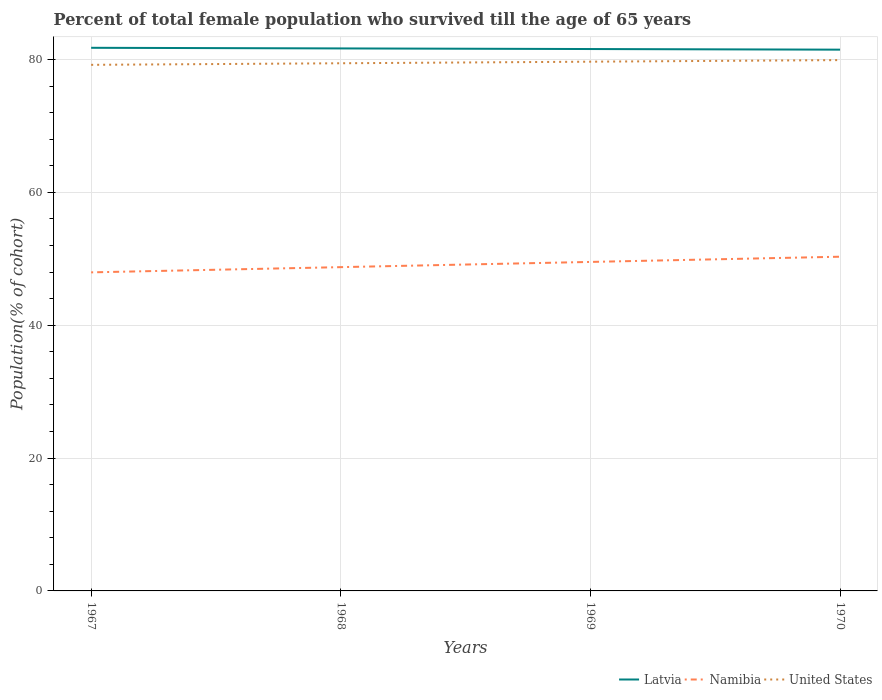Is the number of lines equal to the number of legend labels?
Provide a short and direct response. Yes. Across all years, what is the maximum percentage of total female population who survived till the age of 65 years in United States?
Offer a very short reply. 79.19. In which year was the percentage of total female population who survived till the age of 65 years in Namibia maximum?
Your response must be concise. 1967. What is the total percentage of total female population who survived till the age of 65 years in Namibia in the graph?
Offer a very short reply. -0.78. What is the difference between the highest and the second highest percentage of total female population who survived till the age of 65 years in Namibia?
Give a very brief answer. 2.35. What is the difference between the highest and the lowest percentage of total female population who survived till the age of 65 years in Namibia?
Provide a short and direct response. 2. How many lines are there?
Your response must be concise. 3. What is the difference between two consecutive major ticks on the Y-axis?
Provide a succinct answer. 20. Are the values on the major ticks of Y-axis written in scientific E-notation?
Make the answer very short. No. Does the graph contain any zero values?
Provide a succinct answer. No. Where does the legend appear in the graph?
Provide a succinct answer. Bottom right. How many legend labels are there?
Ensure brevity in your answer.  3. How are the legend labels stacked?
Offer a very short reply. Horizontal. What is the title of the graph?
Your response must be concise. Percent of total female population who survived till the age of 65 years. What is the label or title of the Y-axis?
Your response must be concise. Population(% of cohort). What is the Population(% of cohort) of Latvia in 1967?
Your answer should be compact. 81.76. What is the Population(% of cohort) in Namibia in 1967?
Your response must be concise. 47.95. What is the Population(% of cohort) in United States in 1967?
Your response must be concise. 79.19. What is the Population(% of cohort) of Latvia in 1968?
Your response must be concise. 81.66. What is the Population(% of cohort) in Namibia in 1968?
Your answer should be very brief. 48.74. What is the Population(% of cohort) in United States in 1968?
Offer a terse response. 79.43. What is the Population(% of cohort) in Latvia in 1969?
Your answer should be very brief. 81.57. What is the Population(% of cohort) in Namibia in 1969?
Make the answer very short. 49.52. What is the Population(% of cohort) in United States in 1969?
Ensure brevity in your answer.  79.67. What is the Population(% of cohort) of Latvia in 1970?
Keep it short and to the point. 81.48. What is the Population(% of cohort) in Namibia in 1970?
Ensure brevity in your answer.  50.31. What is the Population(% of cohort) of United States in 1970?
Keep it short and to the point. 79.9. Across all years, what is the maximum Population(% of cohort) of Latvia?
Keep it short and to the point. 81.76. Across all years, what is the maximum Population(% of cohort) in Namibia?
Offer a terse response. 50.31. Across all years, what is the maximum Population(% of cohort) in United States?
Your answer should be compact. 79.9. Across all years, what is the minimum Population(% of cohort) of Latvia?
Your response must be concise. 81.48. Across all years, what is the minimum Population(% of cohort) in Namibia?
Ensure brevity in your answer.  47.95. Across all years, what is the minimum Population(% of cohort) in United States?
Offer a very short reply. 79.19. What is the total Population(% of cohort) of Latvia in the graph?
Your answer should be very brief. 326.47. What is the total Population(% of cohort) in Namibia in the graph?
Your answer should be compact. 196.53. What is the total Population(% of cohort) of United States in the graph?
Provide a succinct answer. 318.19. What is the difference between the Population(% of cohort) in Latvia in 1967 and that in 1968?
Keep it short and to the point. 0.09. What is the difference between the Population(% of cohort) of Namibia in 1967 and that in 1968?
Make the answer very short. -0.79. What is the difference between the Population(% of cohort) of United States in 1967 and that in 1968?
Your answer should be compact. -0.24. What is the difference between the Population(% of cohort) in Latvia in 1967 and that in 1969?
Your answer should be compact. 0.19. What is the difference between the Population(% of cohort) in Namibia in 1967 and that in 1969?
Keep it short and to the point. -1.57. What is the difference between the Population(% of cohort) of United States in 1967 and that in 1969?
Your answer should be very brief. -0.47. What is the difference between the Population(% of cohort) in Latvia in 1967 and that in 1970?
Make the answer very short. 0.28. What is the difference between the Population(% of cohort) in Namibia in 1967 and that in 1970?
Ensure brevity in your answer.  -2.35. What is the difference between the Population(% of cohort) in United States in 1967 and that in 1970?
Your answer should be compact. -0.71. What is the difference between the Population(% of cohort) of Latvia in 1968 and that in 1969?
Offer a very short reply. 0.09. What is the difference between the Population(% of cohort) in Namibia in 1968 and that in 1969?
Ensure brevity in your answer.  -0.79. What is the difference between the Population(% of cohort) of United States in 1968 and that in 1969?
Provide a short and direct response. -0.24. What is the difference between the Population(% of cohort) of Latvia in 1968 and that in 1970?
Your answer should be compact. 0.19. What is the difference between the Population(% of cohort) in Namibia in 1968 and that in 1970?
Your answer should be compact. -1.57. What is the difference between the Population(% of cohort) in United States in 1968 and that in 1970?
Your response must be concise. -0.47. What is the difference between the Population(% of cohort) in Latvia in 1969 and that in 1970?
Provide a succinct answer. 0.09. What is the difference between the Population(% of cohort) of Namibia in 1969 and that in 1970?
Your answer should be compact. -0.79. What is the difference between the Population(% of cohort) in United States in 1969 and that in 1970?
Give a very brief answer. -0.24. What is the difference between the Population(% of cohort) in Latvia in 1967 and the Population(% of cohort) in Namibia in 1968?
Ensure brevity in your answer.  33.02. What is the difference between the Population(% of cohort) of Latvia in 1967 and the Population(% of cohort) of United States in 1968?
Your answer should be compact. 2.33. What is the difference between the Population(% of cohort) in Namibia in 1967 and the Population(% of cohort) in United States in 1968?
Provide a short and direct response. -31.48. What is the difference between the Population(% of cohort) of Latvia in 1967 and the Population(% of cohort) of Namibia in 1969?
Provide a succinct answer. 32.23. What is the difference between the Population(% of cohort) of Latvia in 1967 and the Population(% of cohort) of United States in 1969?
Ensure brevity in your answer.  2.09. What is the difference between the Population(% of cohort) of Namibia in 1967 and the Population(% of cohort) of United States in 1969?
Your answer should be compact. -31.71. What is the difference between the Population(% of cohort) in Latvia in 1967 and the Population(% of cohort) in Namibia in 1970?
Ensure brevity in your answer.  31.45. What is the difference between the Population(% of cohort) in Latvia in 1967 and the Population(% of cohort) in United States in 1970?
Your answer should be very brief. 1.85. What is the difference between the Population(% of cohort) of Namibia in 1967 and the Population(% of cohort) of United States in 1970?
Offer a very short reply. -31.95. What is the difference between the Population(% of cohort) in Latvia in 1968 and the Population(% of cohort) in Namibia in 1969?
Keep it short and to the point. 32.14. What is the difference between the Population(% of cohort) in Latvia in 1968 and the Population(% of cohort) in United States in 1969?
Offer a very short reply. 2. What is the difference between the Population(% of cohort) in Namibia in 1968 and the Population(% of cohort) in United States in 1969?
Provide a succinct answer. -30.93. What is the difference between the Population(% of cohort) of Latvia in 1968 and the Population(% of cohort) of Namibia in 1970?
Provide a succinct answer. 31.35. What is the difference between the Population(% of cohort) in Latvia in 1968 and the Population(% of cohort) in United States in 1970?
Ensure brevity in your answer.  1.76. What is the difference between the Population(% of cohort) in Namibia in 1968 and the Population(% of cohort) in United States in 1970?
Your response must be concise. -31.17. What is the difference between the Population(% of cohort) of Latvia in 1969 and the Population(% of cohort) of Namibia in 1970?
Your response must be concise. 31.26. What is the difference between the Population(% of cohort) of Latvia in 1969 and the Population(% of cohort) of United States in 1970?
Your response must be concise. 1.67. What is the difference between the Population(% of cohort) in Namibia in 1969 and the Population(% of cohort) in United States in 1970?
Provide a succinct answer. -30.38. What is the average Population(% of cohort) in Latvia per year?
Give a very brief answer. 81.62. What is the average Population(% of cohort) of Namibia per year?
Your response must be concise. 49.13. What is the average Population(% of cohort) of United States per year?
Your response must be concise. 79.55. In the year 1967, what is the difference between the Population(% of cohort) of Latvia and Population(% of cohort) of Namibia?
Make the answer very short. 33.8. In the year 1967, what is the difference between the Population(% of cohort) in Latvia and Population(% of cohort) in United States?
Offer a very short reply. 2.56. In the year 1967, what is the difference between the Population(% of cohort) of Namibia and Population(% of cohort) of United States?
Offer a terse response. -31.24. In the year 1968, what is the difference between the Population(% of cohort) in Latvia and Population(% of cohort) in Namibia?
Your response must be concise. 32.92. In the year 1968, what is the difference between the Population(% of cohort) in Latvia and Population(% of cohort) in United States?
Make the answer very short. 2.23. In the year 1968, what is the difference between the Population(% of cohort) in Namibia and Population(% of cohort) in United States?
Ensure brevity in your answer.  -30.69. In the year 1969, what is the difference between the Population(% of cohort) of Latvia and Population(% of cohort) of Namibia?
Your response must be concise. 32.05. In the year 1969, what is the difference between the Population(% of cohort) in Latvia and Population(% of cohort) in United States?
Offer a terse response. 1.9. In the year 1969, what is the difference between the Population(% of cohort) in Namibia and Population(% of cohort) in United States?
Your response must be concise. -30.14. In the year 1970, what is the difference between the Population(% of cohort) of Latvia and Population(% of cohort) of Namibia?
Offer a terse response. 31.17. In the year 1970, what is the difference between the Population(% of cohort) in Latvia and Population(% of cohort) in United States?
Offer a very short reply. 1.57. In the year 1970, what is the difference between the Population(% of cohort) in Namibia and Population(% of cohort) in United States?
Provide a short and direct response. -29.6. What is the ratio of the Population(% of cohort) of Namibia in 1967 to that in 1968?
Offer a terse response. 0.98. What is the ratio of the Population(% of cohort) of United States in 1967 to that in 1968?
Keep it short and to the point. 1. What is the ratio of the Population(% of cohort) of Latvia in 1967 to that in 1969?
Offer a terse response. 1. What is the ratio of the Population(% of cohort) of Namibia in 1967 to that in 1969?
Offer a very short reply. 0.97. What is the ratio of the Population(% of cohort) of Latvia in 1967 to that in 1970?
Keep it short and to the point. 1. What is the ratio of the Population(% of cohort) in Namibia in 1967 to that in 1970?
Keep it short and to the point. 0.95. What is the ratio of the Population(% of cohort) in United States in 1967 to that in 1970?
Offer a terse response. 0.99. What is the ratio of the Population(% of cohort) in Latvia in 1968 to that in 1969?
Your answer should be compact. 1. What is the ratio of the Population(% of cohort) of Namibia in 1968 to that in 1969?
Make the answer very short. 0.98. What is the ratio of the Population(% of cohort) of United States in 1968 to that in 1969?
Give a very brief answer. 1. What is the ratio of the Population(% of cohort) in Latvia in 1968 to that in 1970?
Your answer should be compact. 1. What is the ratio of the Population(% of cohort) of Namibia in 1968 to that in 1970?
Your answer should be compact. 0.97. What is the ratio of the Population(% of cohort) of Namibia in 1969 to that in 1970?
Ensure brevity in your answer.  0.98. What is the ratio of the Population(% of cohort) in United States in 1969 to that in 1970?
Keep it short and to the point. 1. What is the difference between the highest and the second highest Population(% of cohort) of Latvia?
Offer a terse response. 0.09. What is the difference between the highest and the second highest Population(% of cohort) of Namibia?
Offer a very short reply. 0.79. What is the difference between the highest and the second highest Population(% of cohort) of United States?
Your response must be concise. 0.24. What is the difference between the highest and the lowest Population(% of cohort) of Latvia?
Your response must be concise. 0.28. What is the difference between the highest and the lowest Population(% of cohort) in Namibia?
Offer a very short reply. 2.35. What is the difference between the highest and the lowest Population(% of cohort) in United States?
Your response must be concise. 0.71. 